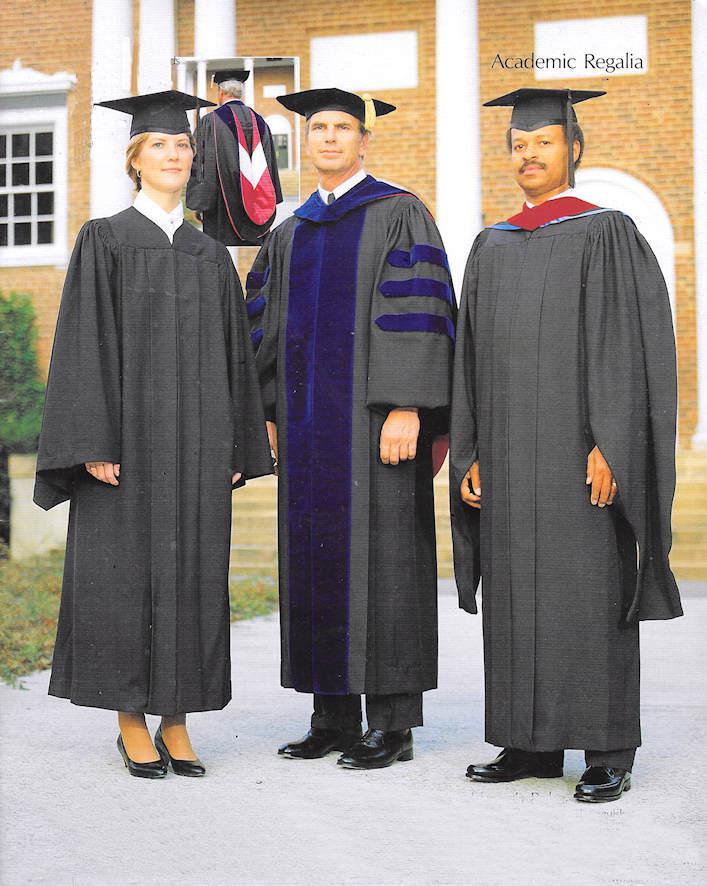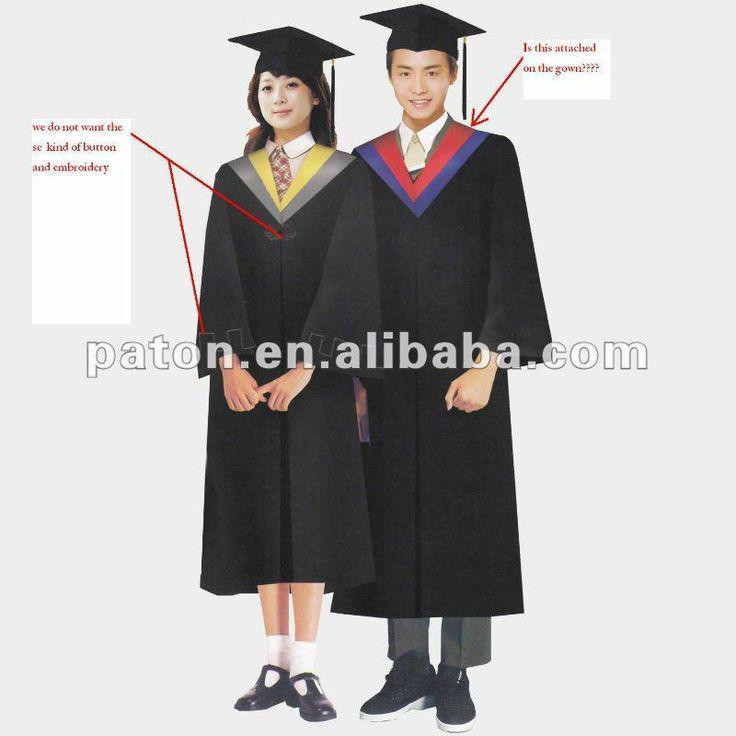The first image is the image on the left, the second image is the image on the right. Considering the images on both sides, is "There are at least two girls outside in one of the images." valid? Answer yes or no. No. 